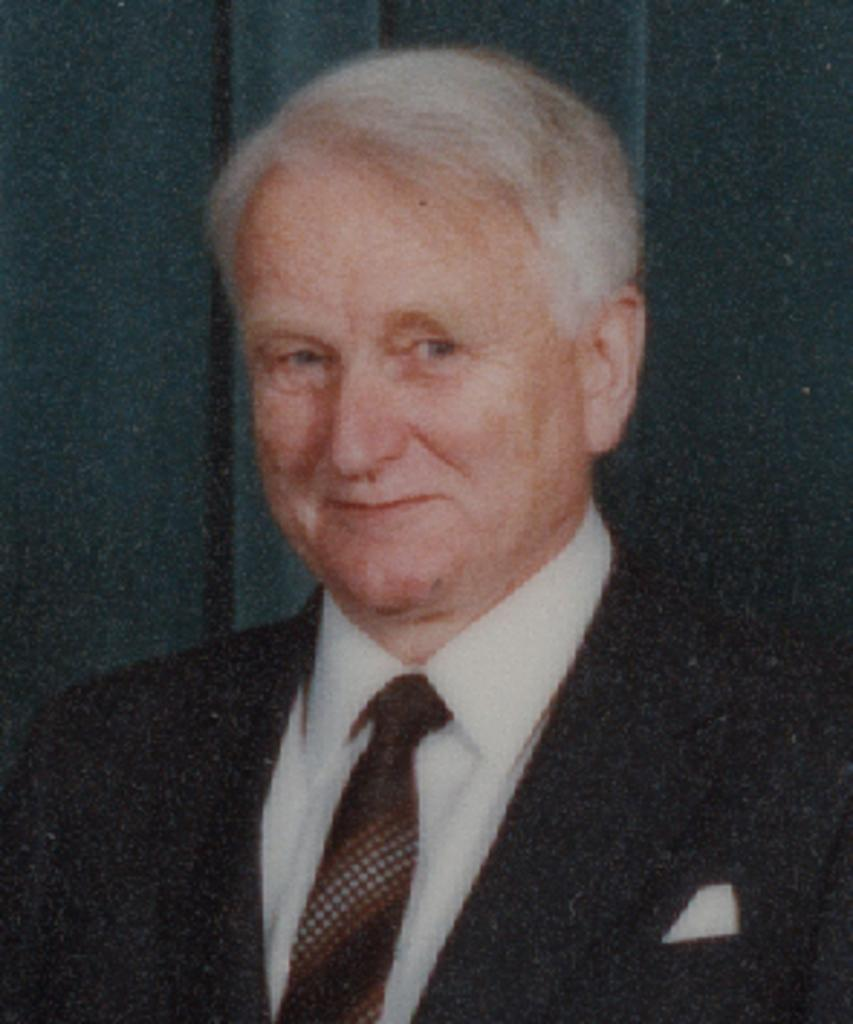Who or what is the main subject of the image? There is a person in the image. What is the person wearing? The person is wearing a suit. How does the person appear to be feeling in the image? The person has a smile on their face, indicating a positive or happy emotion. What can be seen in the background of the image? There is a curtain in the background of the image. What type of toothpaste is the person using in the image? There is no toothpaste present in the image; it features a person wearing a suit and smiling. Is the person wearing a mask in the image? There is no mask visible on the person in the image. 